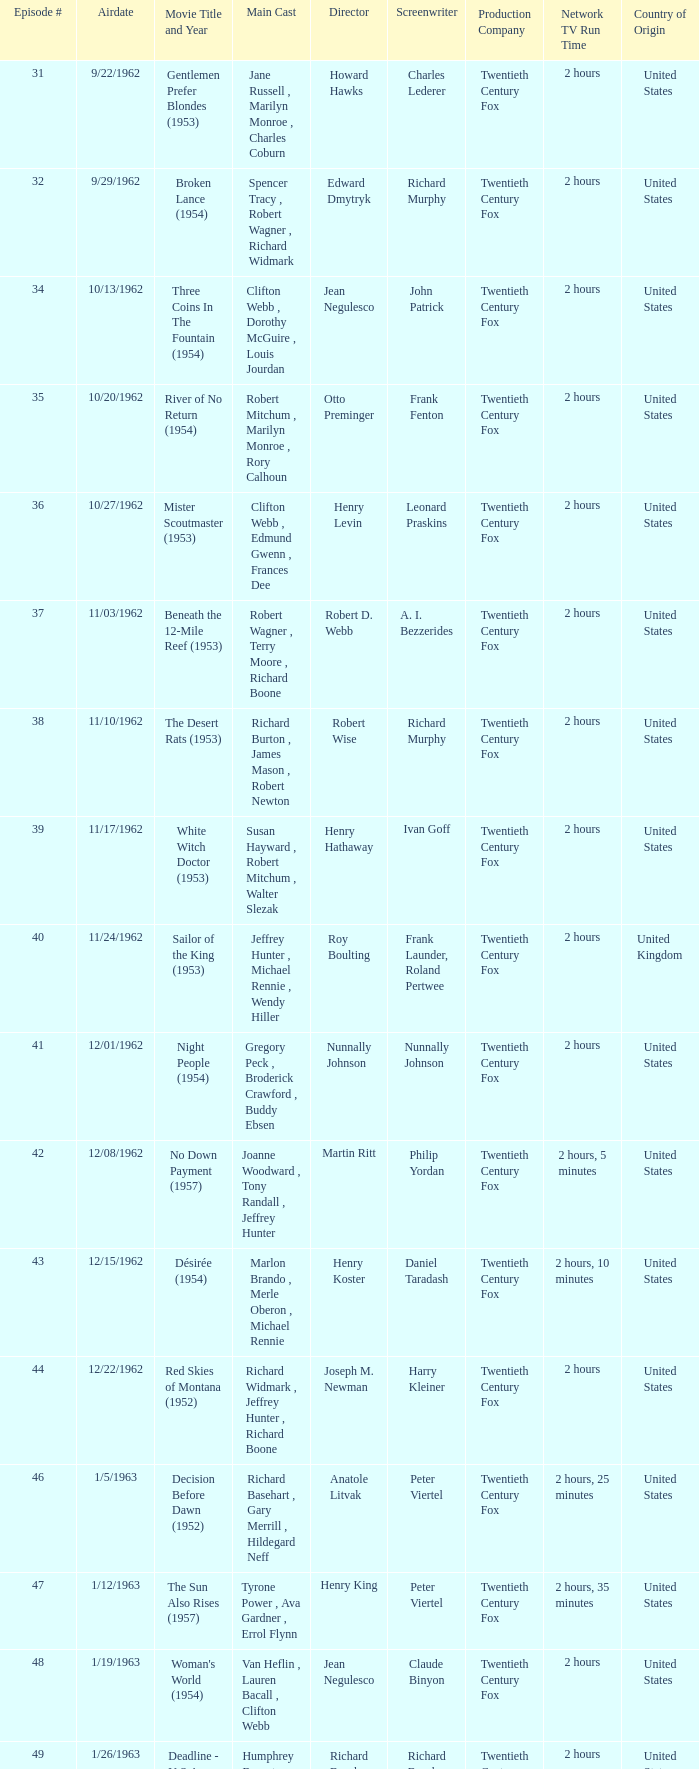What movie did dana wynter , mel ferrer , theodore bikel star in? Fraulein (1958). 